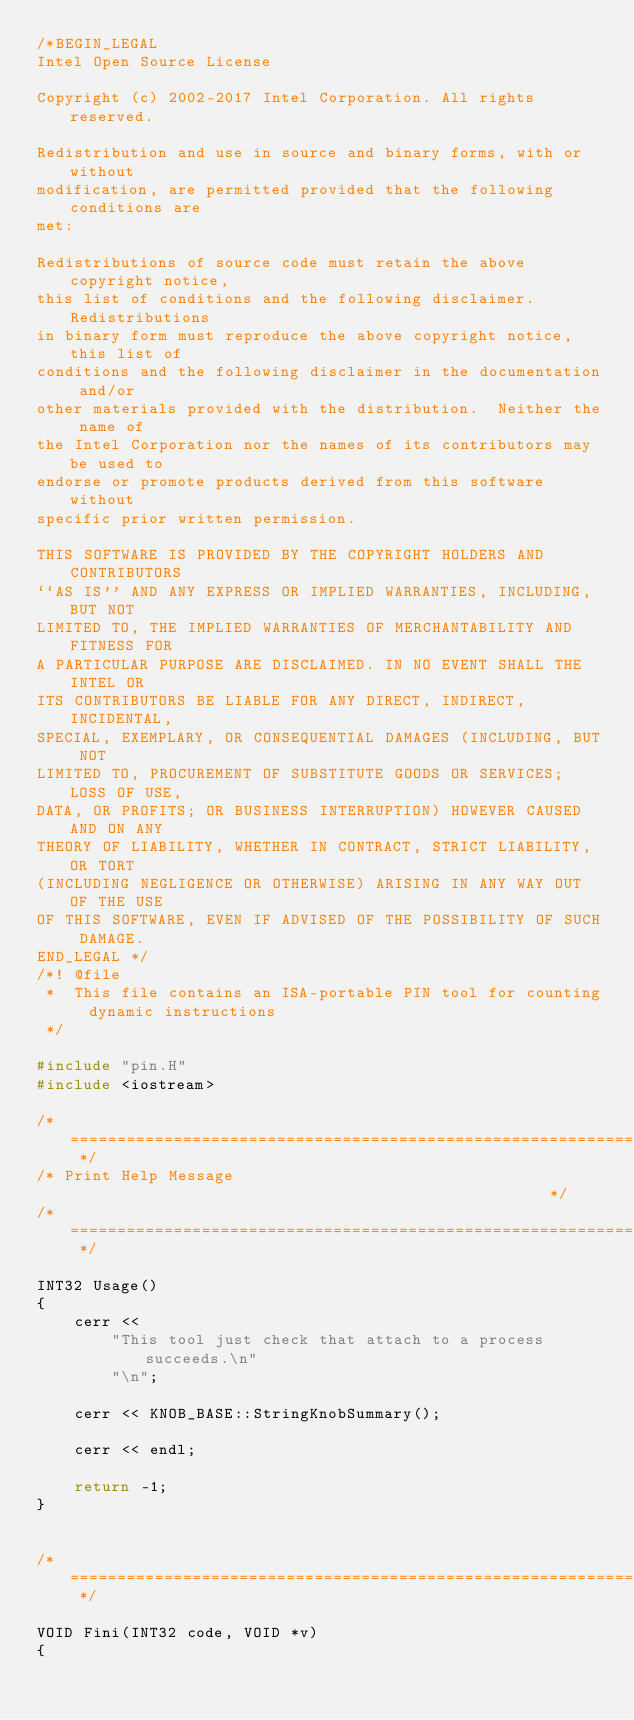Convert code to text. <code><loc_0><loc_0><loc_500><loc_500><_C++_>/*BEGIN_LEGAL 
Intel Open Source License 

Copyright (c) 2002-2017 Intel Corporation. All rights reserved.
 
Redistribution and use in source and binary forms, with or without
modification, are permitted provided that the following conditions are
met:

Redistributions of source code must retain the above copyright notice,
this list of conditions and the following disclaimer.  Redistributions
in binary form must reproduce the above copyright notice, this list of
conditions and the following disclaimer in the documentation and/or
other materials provided with the distribution.  Neither the name of
the Intel Corporation nor the names of its contributors may be used to
endorse or promote products derived from this software without
specific prior written permission.
 
THIS SOFTWARE IS PROVIDED BY THE COPYRIGHT HOLDERS AND CONTRIBUTORS
``AS IS'' AND ANY EXPRESS OR IMPLIED WARRANTIES, INCLUDING, BUT NOT
LIMITED TO, THE IMPLIED WARRANTIES OF MERCHANTABILITY AND FITNESS FOR
A PARTICULAR PURPOSE ARE DISCLAIMED. IN NO EVENT SHALL THE INTEL OR
ITS CONTRIBUTORS BE LIABLE FOR ANY DIRECT, INDIRECT, INCIDENTAL,
SPECIAL, EXEMPLARY, OR CONSEQUENTIAL DAMAGES (INCLUDING, BUT NOT
LIMITED TO, PROCUREMENT OF SUBSTITUTE GOODS OR SERVICES; LOSS OF USE,
DATA, OR PROFITS; OR BUSINESS INTERRUPTION) HOWEVER CAUSED AND ON ANY
THEORY OF LIABILITY, WHETHER IN CONTRACT, STRICT LIABILITY, OR TORT
(INCLUDING NEGLIGENCE OR OTHERWISE) ARISING IN ANY WAY OUT OF THE USE
OF THIS SOFTWARE, EVEN IF ADVISED OF THE POSSIBILITY OF SUCH DAMAGE.
END_LEGAL */
/*! @file
 *  This file contains an ISA-portable PIN tool for counting dynamic instructions
 */

#include "pin.H"
#include <iostream>

/* ===================================================================== */
/* Print Help Message                                                    */
/* ===================================================================== */

INT32 Usage()
{
    cerr <<
        "This tool just check that attach to a process succeeds.\n"
        "\n";

    cerr << KNOB_BASE::StringKnobSummary();

    cerr << endl;

    return -1;
}


/* ===================================================================== */

VOID Fini(INT32 code, VOID *v)
{</code> 